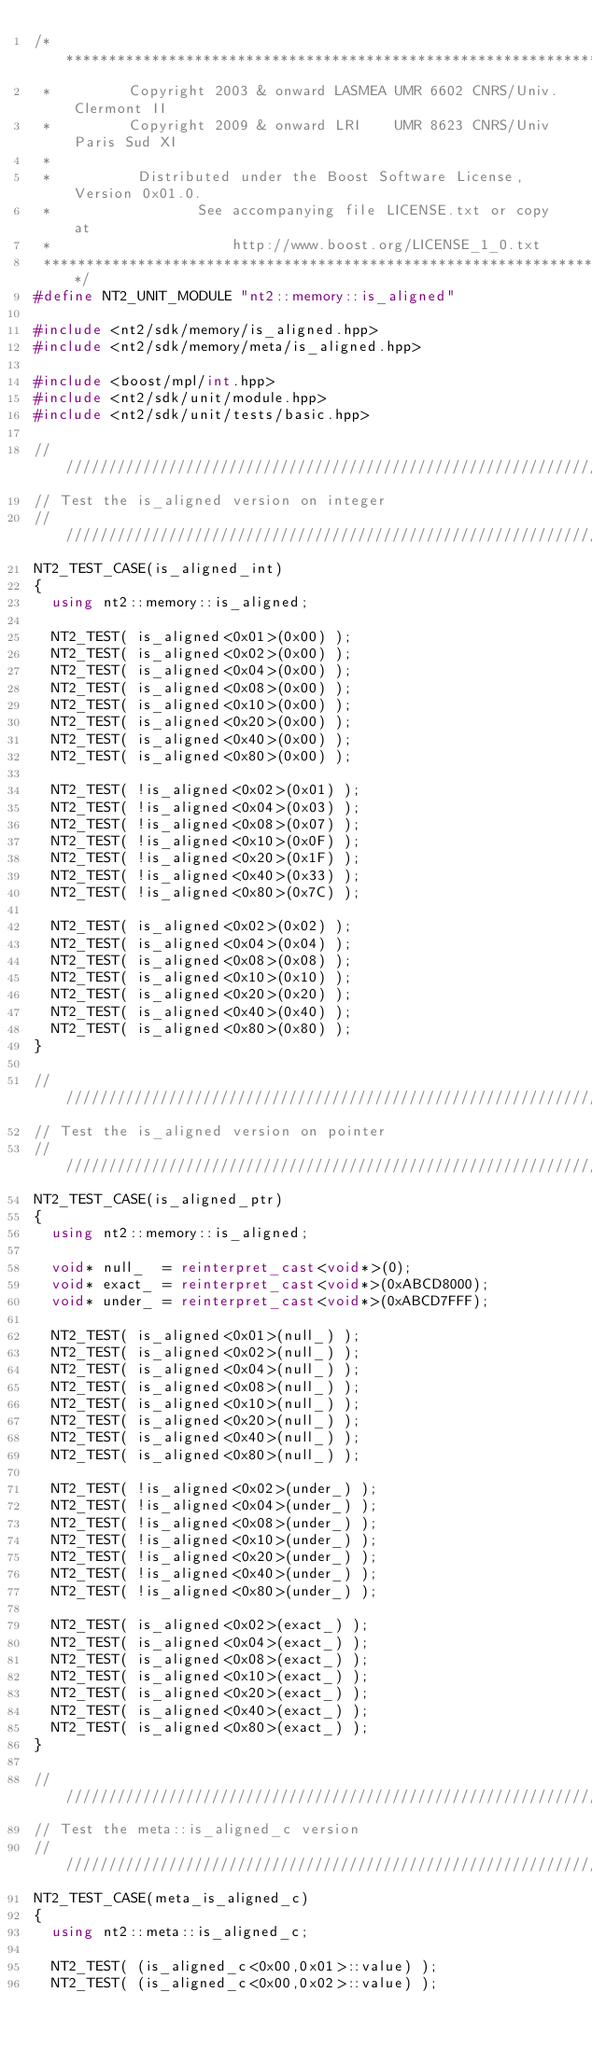<code> <loc_0><loc_0><loc_500><loc_500><_C++_>/*******************************************************************************
 *         Copyright 2003 & onward LASMEA UMR 6602 CNRS/Univ. Clermont II
 *         Copyright 2009 & onward LRI    UMR 8623 CNRS/Univ Paris Sud XI
 *
 *          Distributed under the Boost Software License, Version 0x01.0.
 *                 See accompanying file LICENSE.txt or copy at
 *                     http://www.boost.org/LICENSE_1_0.txt
 ******************************************************************************/
#define NT2_UNIT_MODULE "nt2::memory::is_aligned"

#include <nt2/sdk/memory/is_aligned.hpp>
#include <nt2/sdk/memory/meta/is_aligned.hpp>

#include <boost/mpl/int.hpp>
#include <nt2/sdk/unit/module.hpp>
#include <nt2/sdk/unit/tests/basic.hpp>

////////////////////////////////////////////////////////////////////////////////
// Test the is_aligned version on integer
////////////////////////////////////////////////////////////////////////////////
NT2_TEST_CASE(is_aligned_int)
{
  using nt2::memory::is_aligned;

  NT2_TEST( is_aligned<0x01>(0x00) );
  NT2_TEST( is_aligned<0x02>(0x00) );
  NT2_TEST( is_aligned<0x04>(0x00) );
  NT2_TEST( is_aligned<0x08>(0x00) );
  NT2_TEST( is_aligned<0x10>(0x00) );
  NT2_TEST( is_aligned<0x20>(0x00) );
  NT2_TEST( is_aligned<0x40>(0x00) );
  NT2_TEST( is_aligned<0x80>(0x00) );

  NT2_TEST( !is_aligned<0x02>(0x01) );
  NT2_TEST( !is_aligned<0x04>(0x03) );
  NT2_TEST( !is_aligned<0x08>(0x07) );
  NT2_TEST( !is_aligned<0x10>(0x0F) );
  NT2_TEST( !is_aligned<0x20>(0x1F) );
  NT2_TEST( !is_aligned<0x40>(0x33) );
  NT2_TEST( !is_aligned<0x80>(0x7C) );

  NT2_TEST( is_aligned<0x02>(0x02) );
  NT2_TEST( is_aligned<0x04>(0x04) );
  NT2_TEST( is_aligned<0x08>(0x08) );
  NT2_TEST( is_aligned<0x10>(0x10) );
  NT2_TEST( is_aligned<0x20>(0x20) );
  NT2_TEST( is_aligned<0x40>(0x40) );
  NT2_TEST( is_aligned<0x80>(0x80) );
}

////////////////////////////////////////////////////////////////////////////////
// Test the is_aligned version on pointer
////////////////////////////////////////////////////////////////////////////////
NT2_TEST_CASE(is_aligned_ptr)
{
  using nt2::memory::is_aligned;

  void* null_  = reinterpret_cast<void*>(0);
  void* exact_ = reinterpret_cast<void*>(0xABCD8000);
  void* under_ = reinterpret_cast<void*>(0xABCD7FFF);

  NT2_TEST( is_aligned<0x01>(null_) );
  NT2_TEST( is_aligned<0x02>(null_) );
  NT2_TEST( is_aligned<0x04>(null_) );
  NT2_TEST( is_aligned<0x08>(null_) );
  NT2_TEST( is_aligned<0x10>(null_) );
  NT2_TEST( is_aligned<0x20>(null_) );
  NT2_TEST( is_aligned<0x40>(null_) );
  NT2_TEST( is_aligned<0x80>(null_) );

  NT2_TEST( !is_aligned<0x02>(under_) );
  NT2_TEST( !is_aligned<0x04>(under_) );
  NT2_TEST( !is_aligned<0x08>(under_) );
  NT2_TEST( !is_aligned<0x10>(under_) );
  NT2_TEST( !is_aligned<0x20>(under_) );
  NT2_TEST( !is_aligned<0x40>(under_) );
  NT2_TEST( !is_aligned<0x80>(under_) );

  NT2_TEST( is_aligned<0x02>(exact_) );
  NT2_TEST( is_aligned<0x04>(exact_) );
  NT2_TEST( is_aligned<0x08>(exact_) );
  NT2_TEST( is_aligned<0x10>(exact_) );
  NT2_TEST( is_aligned<0x20>(exact_) );
  NT2_TEST( is_aligned<0x40>(exact_) );
  NT2_TEST( is_aligned<0x80>(exact_) );
}

////////////////////////////////////////////////////////////////////////////////
// Test the meta::is_aligned_c version
////////////////////////////////////////////////////////////////////////////////
NT2_TEST_CASE(meta_is_aligned_c)
{
  using nt2::meta::is_aligned_c;

  NT2_TEST( (is_aligned_c<0x00,0x01>::value) );
  NT2_TEST( (is_aligned_c<0x00,0x02>::value) );</code> 